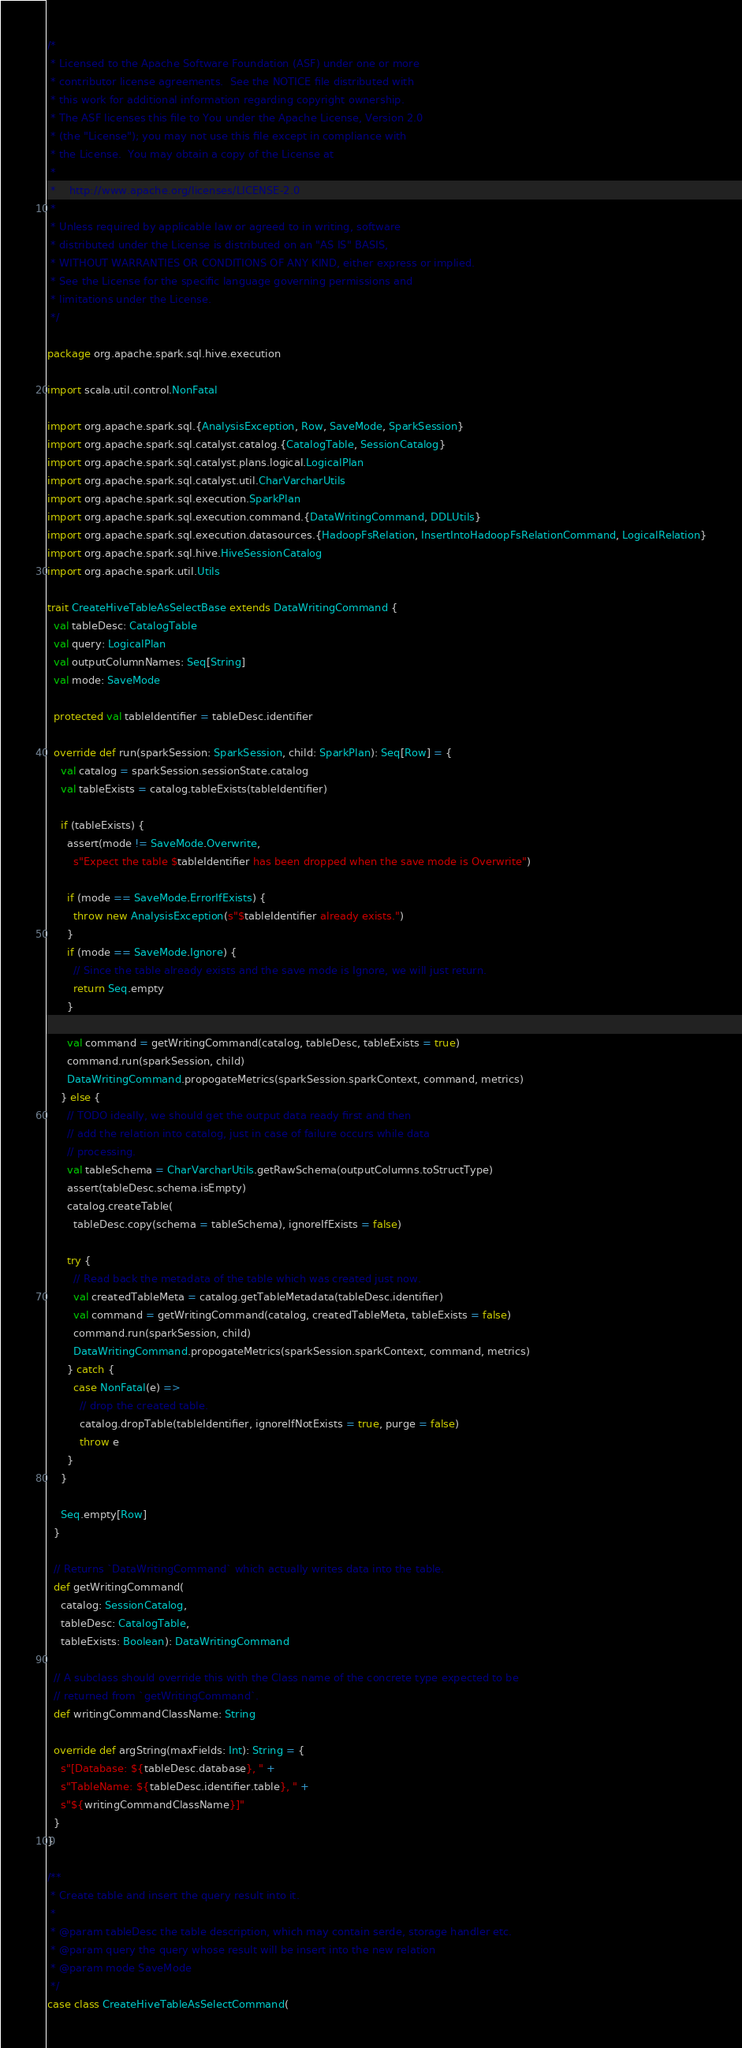Convert code to text. <code><loc_0><loc_0><loc_500><loc_500><_Scala_>/*
 * Licensed to the Apache Software Foundation (ASF) under one or more
 * contributor license agreements.  See the NOTICE file distributed with
 * this work for additional information regarding copyright ownership.
 * The ASF licenses this file to You under the Apache License, Version 2.0
 * (the "License"); you may not use this file except in compliance with
 * the License.  You may obtain a copy of the License at
 *
 *    http://www.apache.org/licenses/LICENSE-2.0
 *
 * Unless required by applicable law or agreed to in writing, software
 * distributed under the License is distributed on an "AS IS" BASIS,
 * WITHOUT WARRANTIES OR CONDITIONS OF ANY KIND, either express or implied.
 * See the License for the specific language governing permissions and
 * limitations under the License.
 */

package org.apache.spark.sql.hive.execution

import scala.util.control.NonFatal

import org.apache.spark.sql.{AnalysisException, Row, SaveMode, SparkSession}
import org.apache.spark.sql.catalyst.catalog.{CatalogTable, SessionCatalog}
import org.apache.spark.sql.catalyst.plans.logical.LogicalPlan
import org.apache.spark.sql.catalyst.util.CharVarcharUtils
import org.apache.spark.sql.execution.SparkPlan
import org.apache.spark.sql.execution.command.{DataWritingCommand, DDLUtils}
import org.apache.spark.sql.execution.datasources.{HadoopFsRelation, InsertIntoHadoopFsRelationCommand, LogicalRelation}
import org.apache.spark.sql.hive.HiveSessionCatalog
import org.apache.spark.util.Utils

trait CreateHiveTableAsSelectBase extends DataWritingCommand {
  val tableDesc: CatalogTable
  val query: LogicalPlan
  val outputColumnNames: Seq[String]
  val mode: SaveMode

  protected val tableIdentifier = tableDesc.identifier

  override def run(sparkSession: SparkSession, child: SparkPlan): Seq[Row] = {
    val catalog = sparkSession.sessionState.catalog
    val tableExists = catalog.tableExists(tableIdentifier)

    if (tableExists) {
      assert(mode != SaveMode.Overwrite,
        s"Expect the table $tableIdentifier has been dropped when the save mode is Overwrite")

      if (mode == SaveMode.ErrorIfExists) {
        throw new AnalysisException(s"$tableIdentifier already exists.")
      }
      if (mode == SaveMode.Ignore) {
        // Since the table already exists and the save mode is Ignore, we will just return.
        return Seq.empty
      }

      val command = getWritingCommand(catalog, tableDesc, tableExists = true)
      command.run(sparkSession, child)
      DataWritingCommand.propogateMetrics(sparkSession.sparkContext, command, metrics)
    } else {
      // TODO ideally, we should get the output data ready first and then
      // add the relation into catalog, just in case of failure occurs while data
      // processing.
      val tableSchema = CharVarcharUtils.getRawSchema(outputColumns.toStructType)
      assert(tableDesc.schema.isEmpty)
      catalog.createTable(
        tableDesc.copy(schema = tableSchema), ignoreIfExists = false)

      try {
        // Read back the metadata of the table which was created just now.
        val createdTableMeta = catalog.getTableMetadata(tableDesc.identifier)
        val command = getWritingCommand(catalog, createdTableMeta, tableExists = false)
        command.run(sparkSession, child)
        DataWritingCommand.propogateMetrics(sparkSession.sparkContext, command, metrics)
      } catch {
        case NonFatal(e) =>
          // drop the created table.
          catalog.dropTable(tableIdentifier, ignoreIfNotExists = true, purge = false)
          throw e
      }
    }

    Seq.empty[Row]
  }

  // Returns `DataWritingCommand` which actually writes data into the table.
  def getWritingCommand(
    catalog: SessionCatalog,
    tableDesc: CatalogTable,
    tableExists: Boolean): DataWritingCommand

  // A subclass should override this with the Class name of the concrete type expected to be
  // returned from `getWritingCommand`.
  def writingCommandClassName: String

  override def argString(maxFields: Int): String = {
    s"[Database: ${tableDesc.database}, " +
    s"TableName: ${tableDesc.identifier.table}, " +
    s"${writingCommandClassName}]"
  }
}

/**
 * Create table and insert the query result into it.
 *
 * @param tableDesc the table description, which may contain serde, storage handler etc.
 * @param query the query whose result will be insert into the new relation
 * @param mode SaveMode
 */
case class CreateHiveTableAsSelectCommand(</code> 